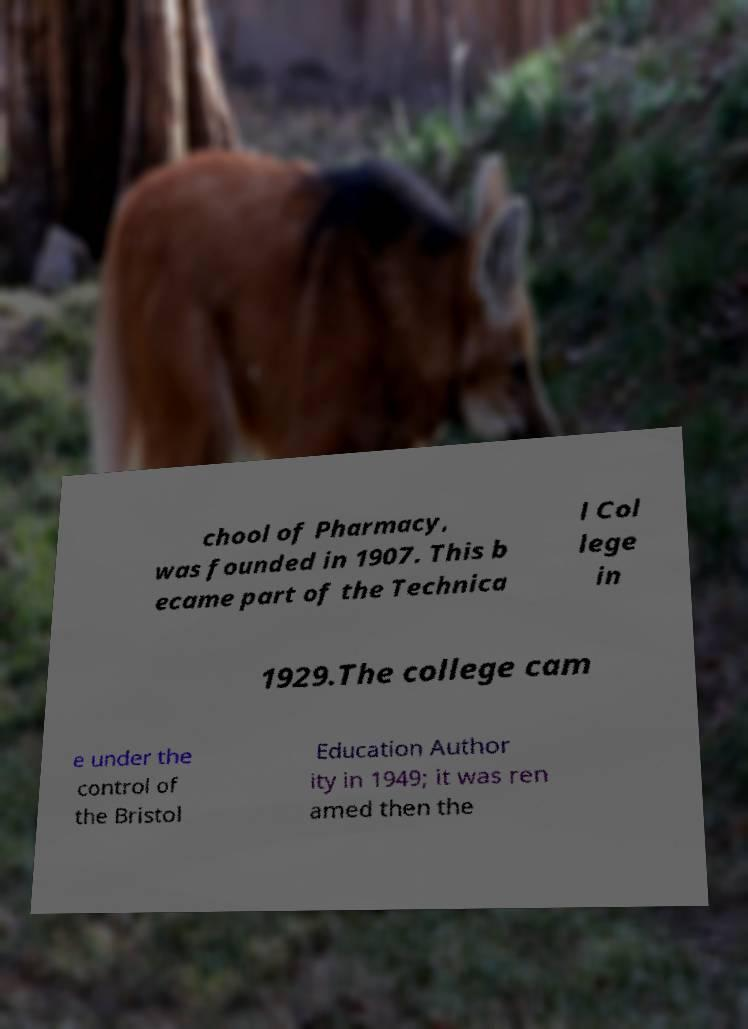Could you assist in decoding the text presented in this image and type it out clearly? chool of Pharmacy, was founded in 1907. This b ecame part of the Technica l Col lege in 1929.The college cam e under the control of the Bristol Education Author ity in 1949; it was ren amed then the 